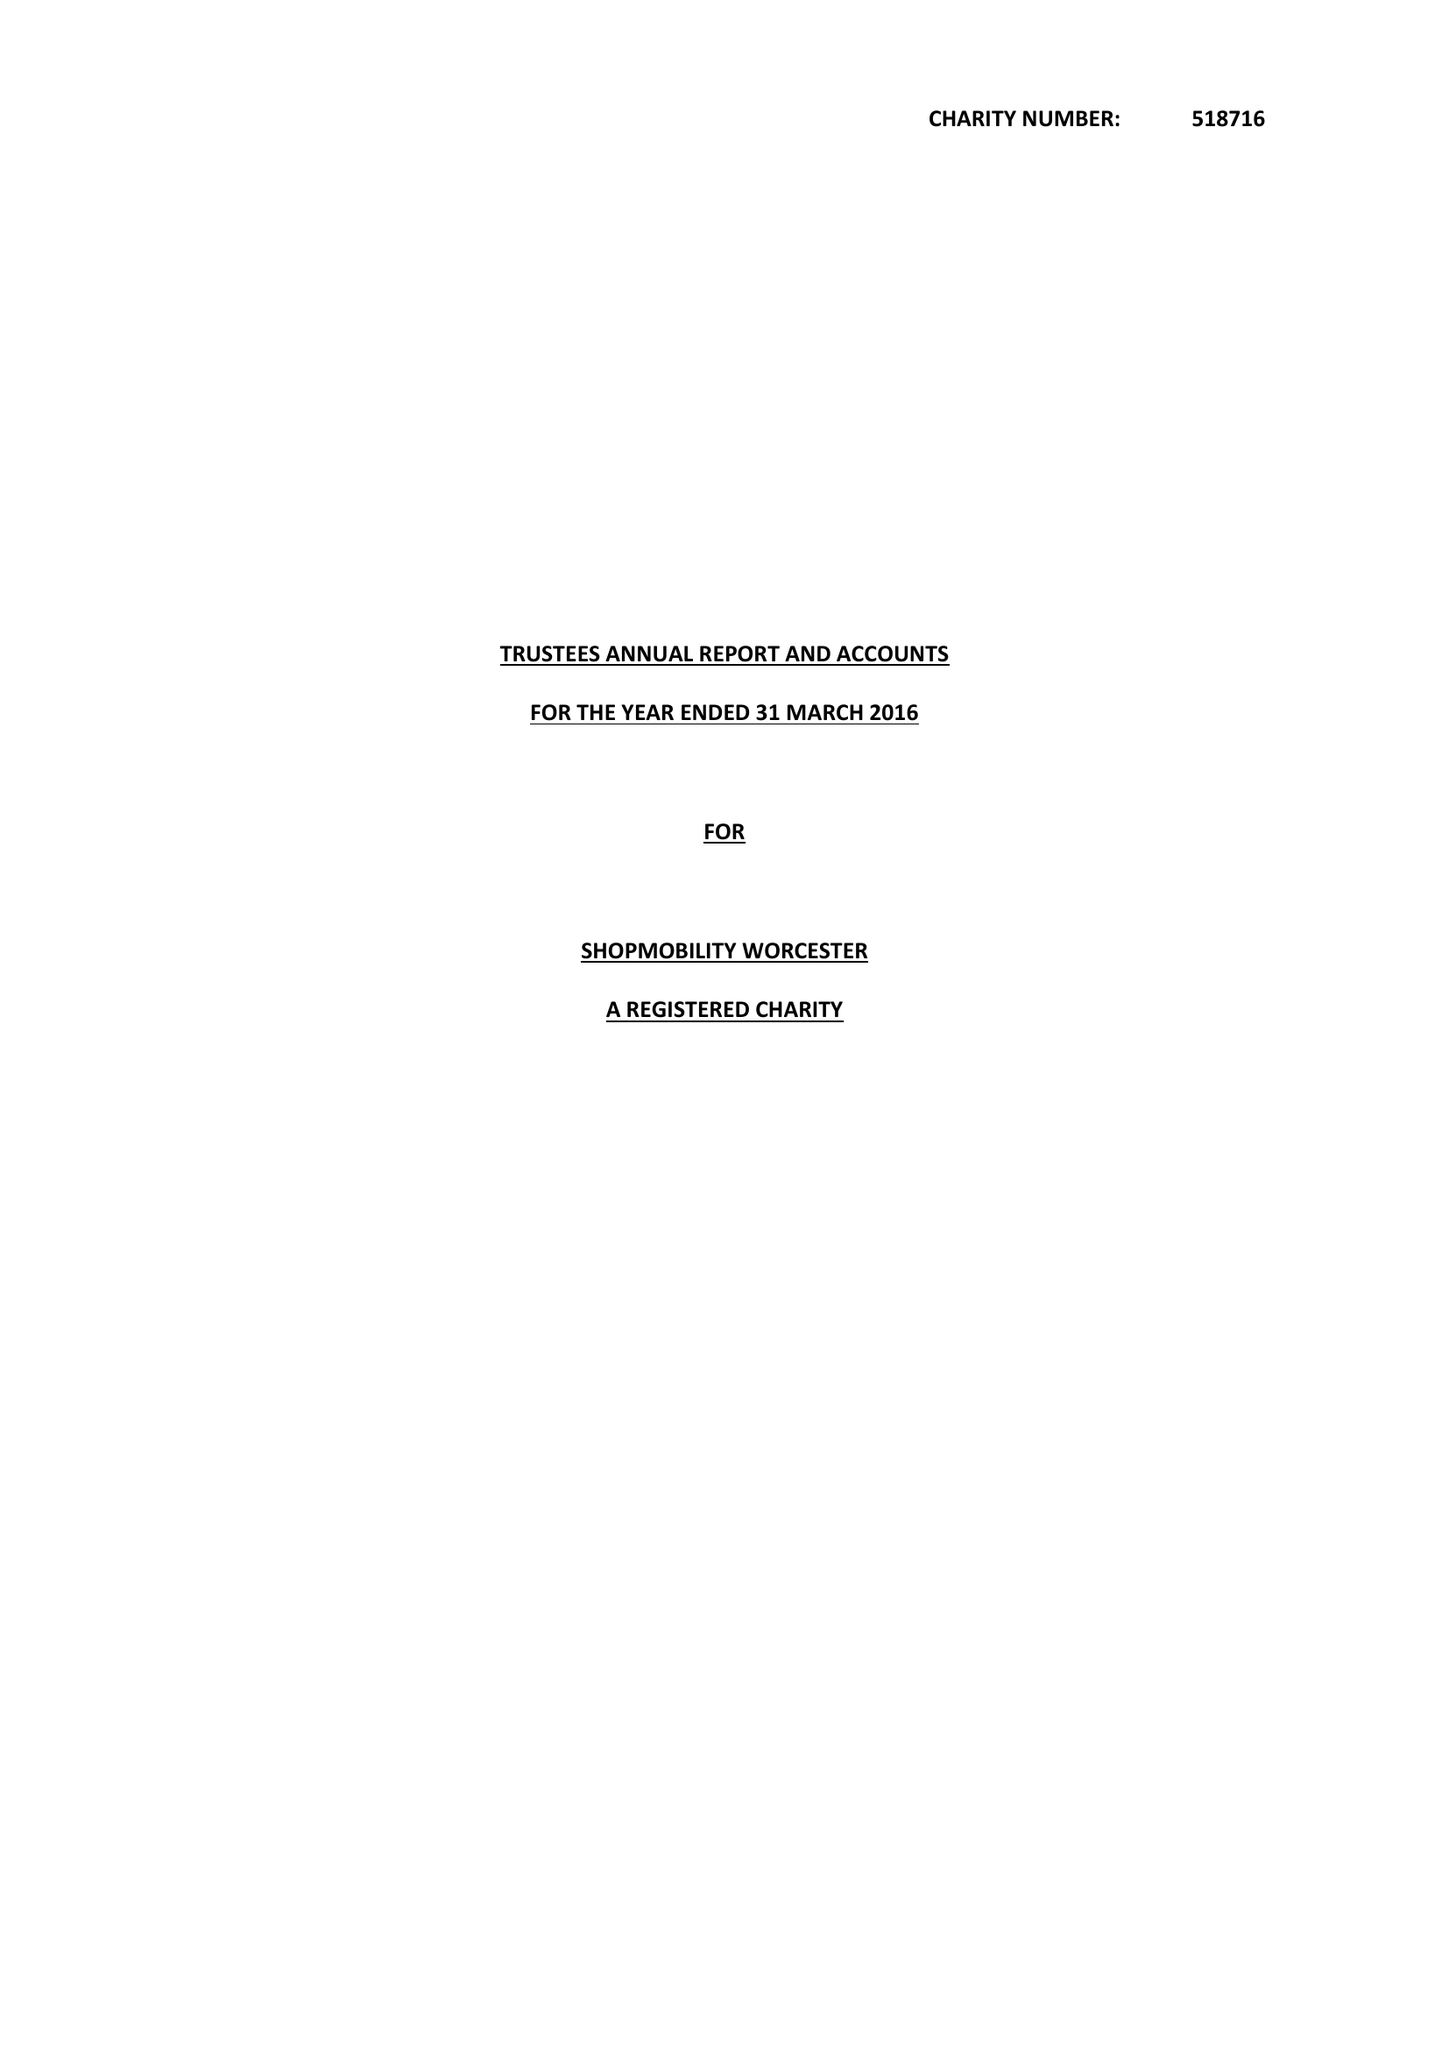What is the value for the charity_name?
Answer the question using a single word or phrase. Shopmobility Worcester 